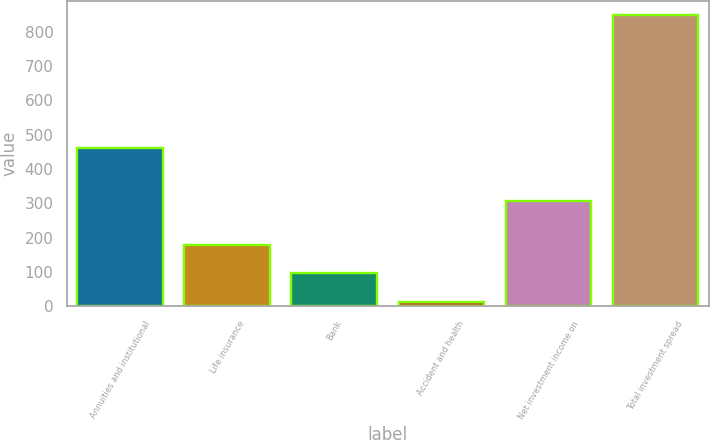Convert chart to OTSL. <chart><loc_0><loc_0><loc_500><loc_500><bar_chart><fcel>Annuities and institutional<fcel>Life insurance<fcel>Bank<fcel>Accident and health<fcel>Net investment income on<fcel>Total investment spread<nl><fcel>460<fcel>179.2<fcel>95.6<fcel>12<fcel>306<fcel>848<nl></chart> 